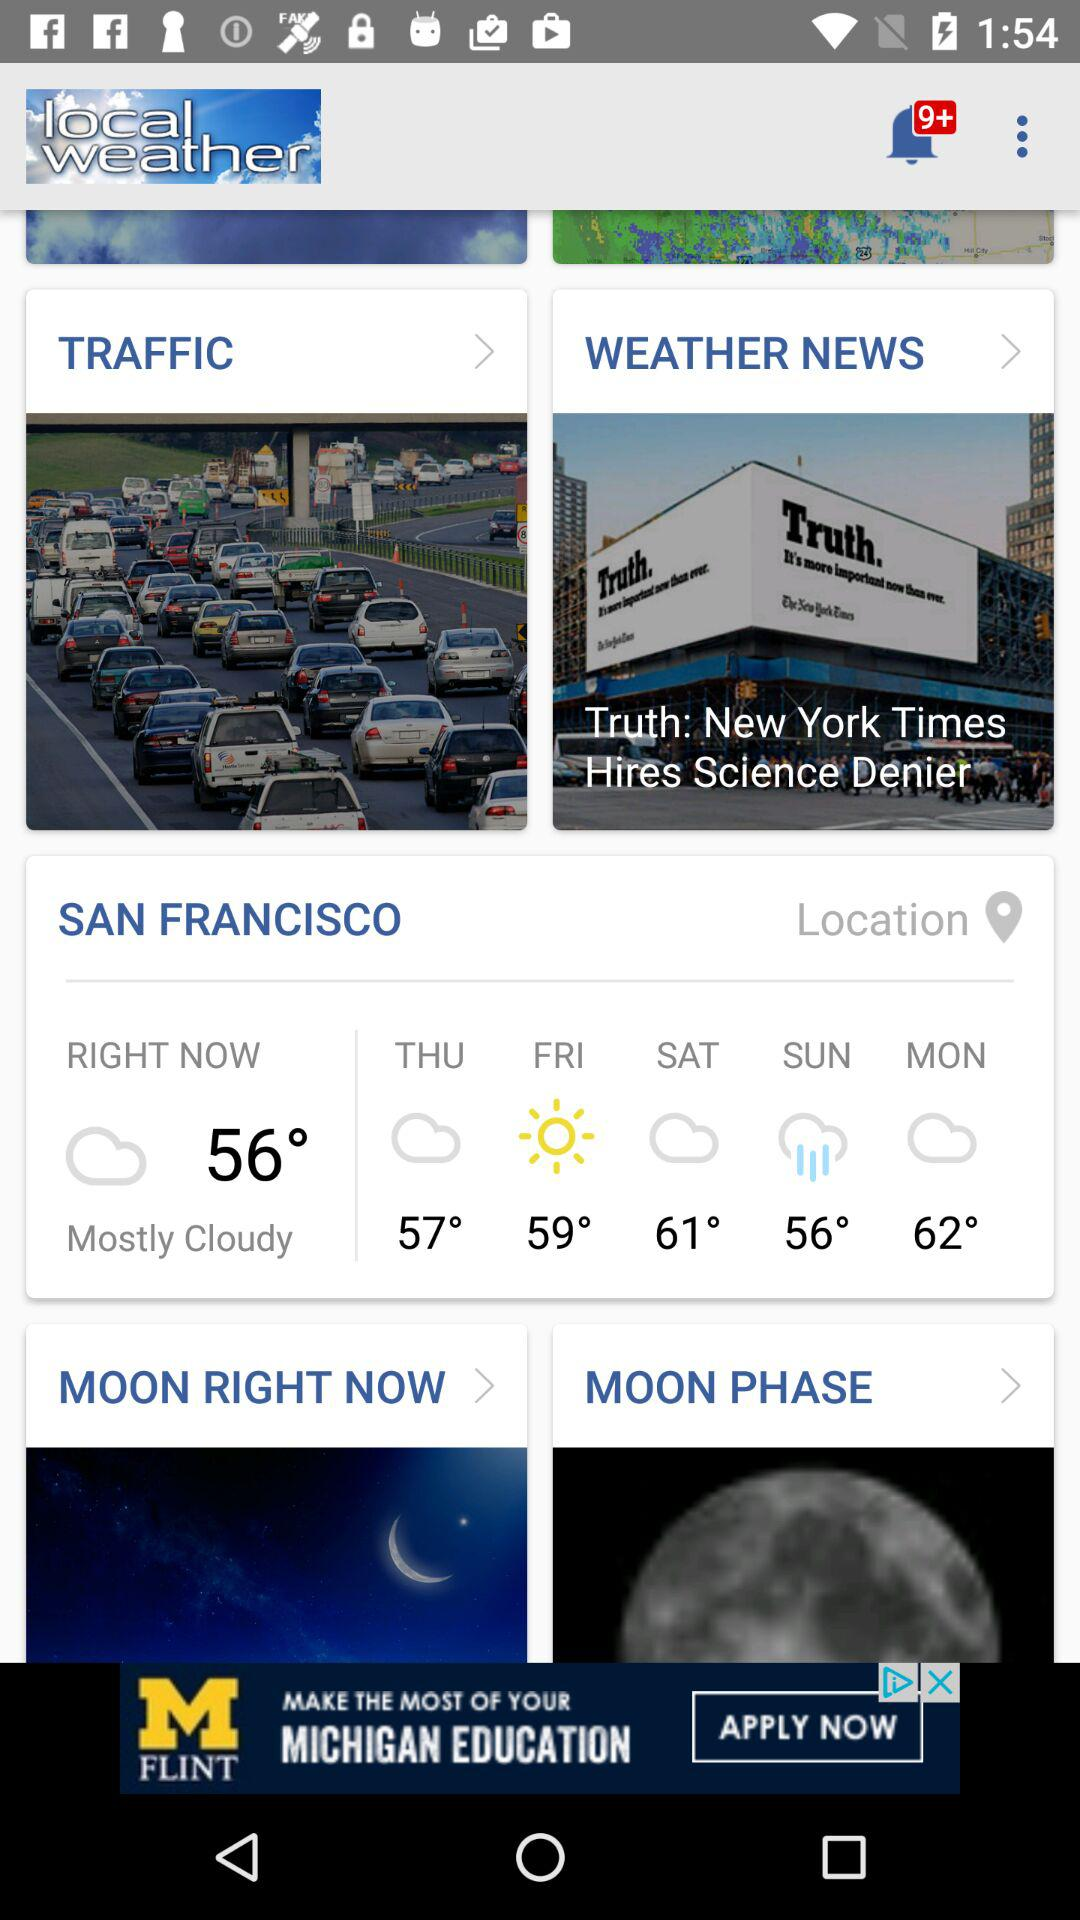What is the location? The location is San Francisco. 